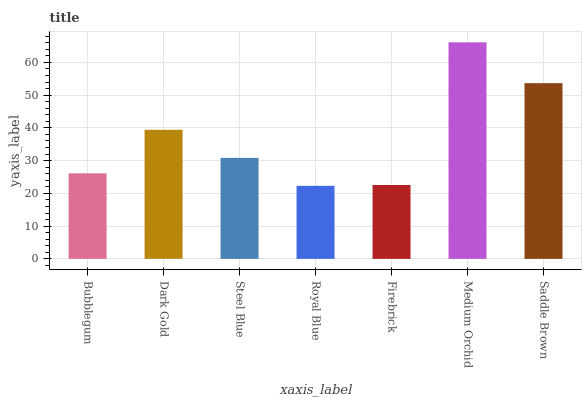Is Dark Gold the minimum?
Answer yes or no. No. Is Dark Gold the maximum?
Answer yes or no. No. Is Dark Gold greater than Bubblegum?
Answer yes or no. Yes. Is Bubblegum less than Dark Gold?
Answer yes or no. Yes. Is Bubblegum greater than Dark Gold?
Answer yes or no. No. Is Dark Gold less than Bubblegum?
Answer yes or no. No. Is Steel Blue the high median?
Answer yes or no. Yes. Is Steel Blue the low median?
Answer yes or no. Yes. Is Bubblegum the high median?
Answer yes or no. No. Is Medium Orchid the low median?
Answer yes or no. No. 